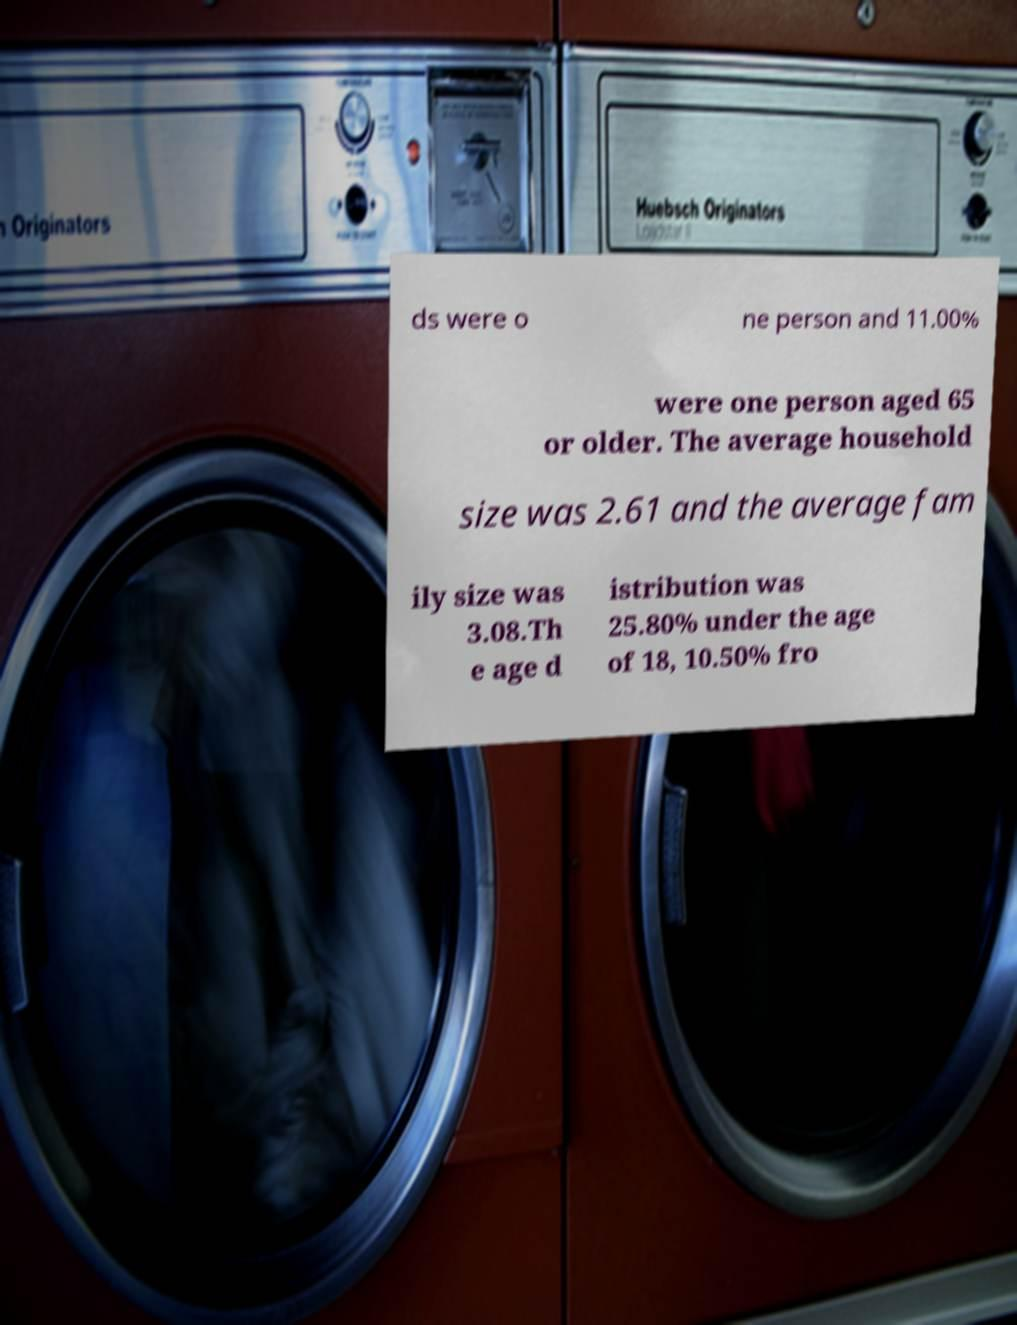Please read and relay the text visible in this image. What does it say? ds were o ne person and 11.00% were one person aged 65 or older. The average household size was 2.61 and the average fam ily size was 3.08.Th e age d istribution was 25.80% under the age of 18, 10.50% fro 